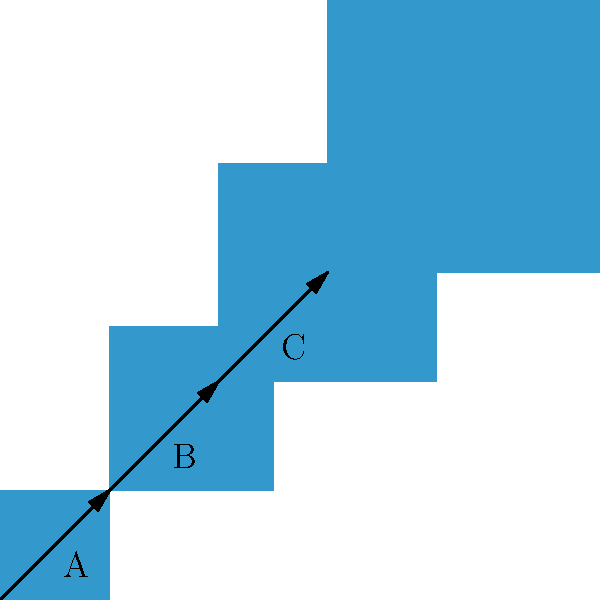In our community's symbolic pattern of growth, each square represents a stage of progress. If the transformation from one stage to the next is represented by vectors A, B, and C, what vector would represent the direct transformation from the first to the last stage? To find the vector that represents the direct transformation from the first to the last stage, we need to add the individual transformation vectors:

1. Vector A transforms the first square to the second: $A = \langle 1, 1 \rangle$
2. Vector B transforms the second square to the third: $B = \langle 1, 1 \rangle$
3. Vector C transforms the third square to the fourth: $C = \langle 1, 1 \rangle$

The direct transformation vector is the sum of these vectors:

$$D = A + B + C = \langle 1, 1 \rangle + \langle 1, 1 \rangle + \langle 1, 1 \rangle = \langle 3, 3 \rangle$$

This vector $\langle 3, 3 \rangle$ represents the total growth and progress from the first to the last stage in our community's symbolic pattern.
Answer: $\langle 3, 3 \rangle$ 